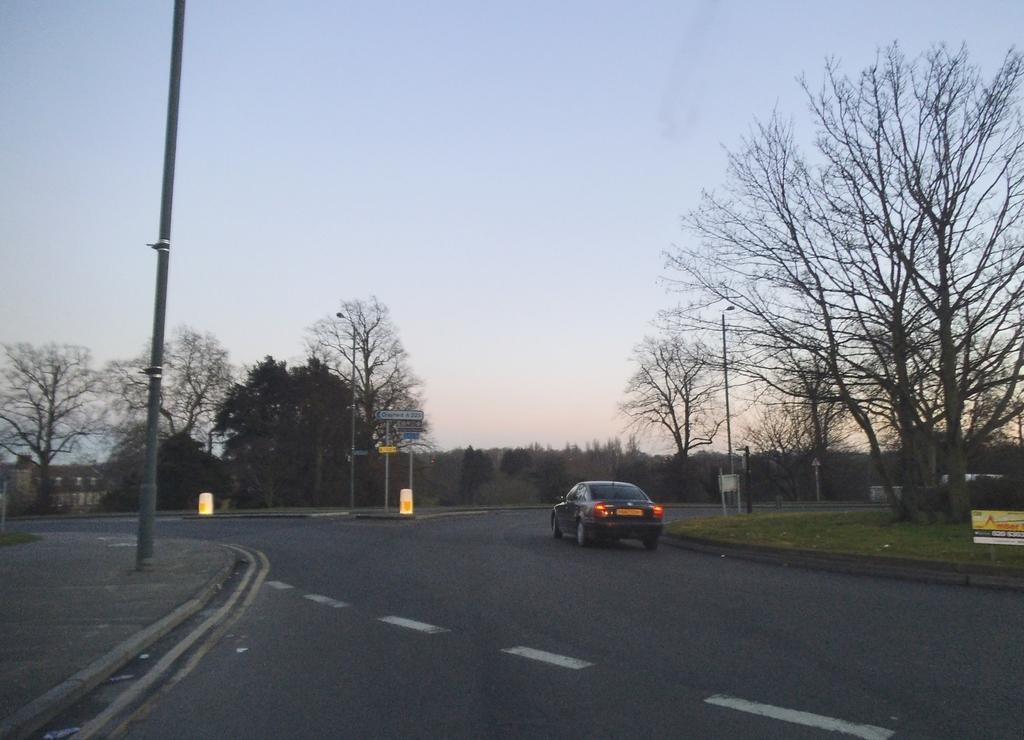How would you summarize this image in a sentence or two? In this image we can see a car is moving on the road. Here we can see few white lines. Right side of the image, we can see few boards with rods. From right side to the left side, we can see few trees, poles, signboards. Left side of the image, we can see a house. Top of the image, there is a sky. 